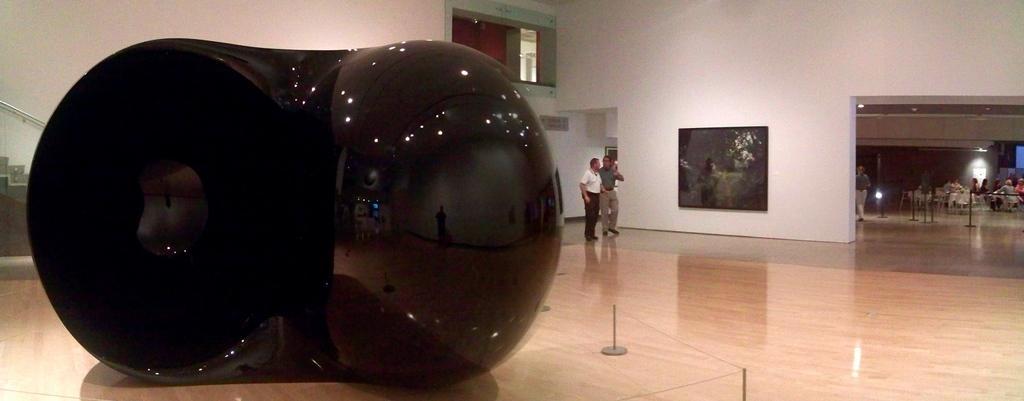Can you describe this image briefly? There is a black color object in the foreground area of the image, there are people, lamps, it seems like chairs and other objects in the background. 